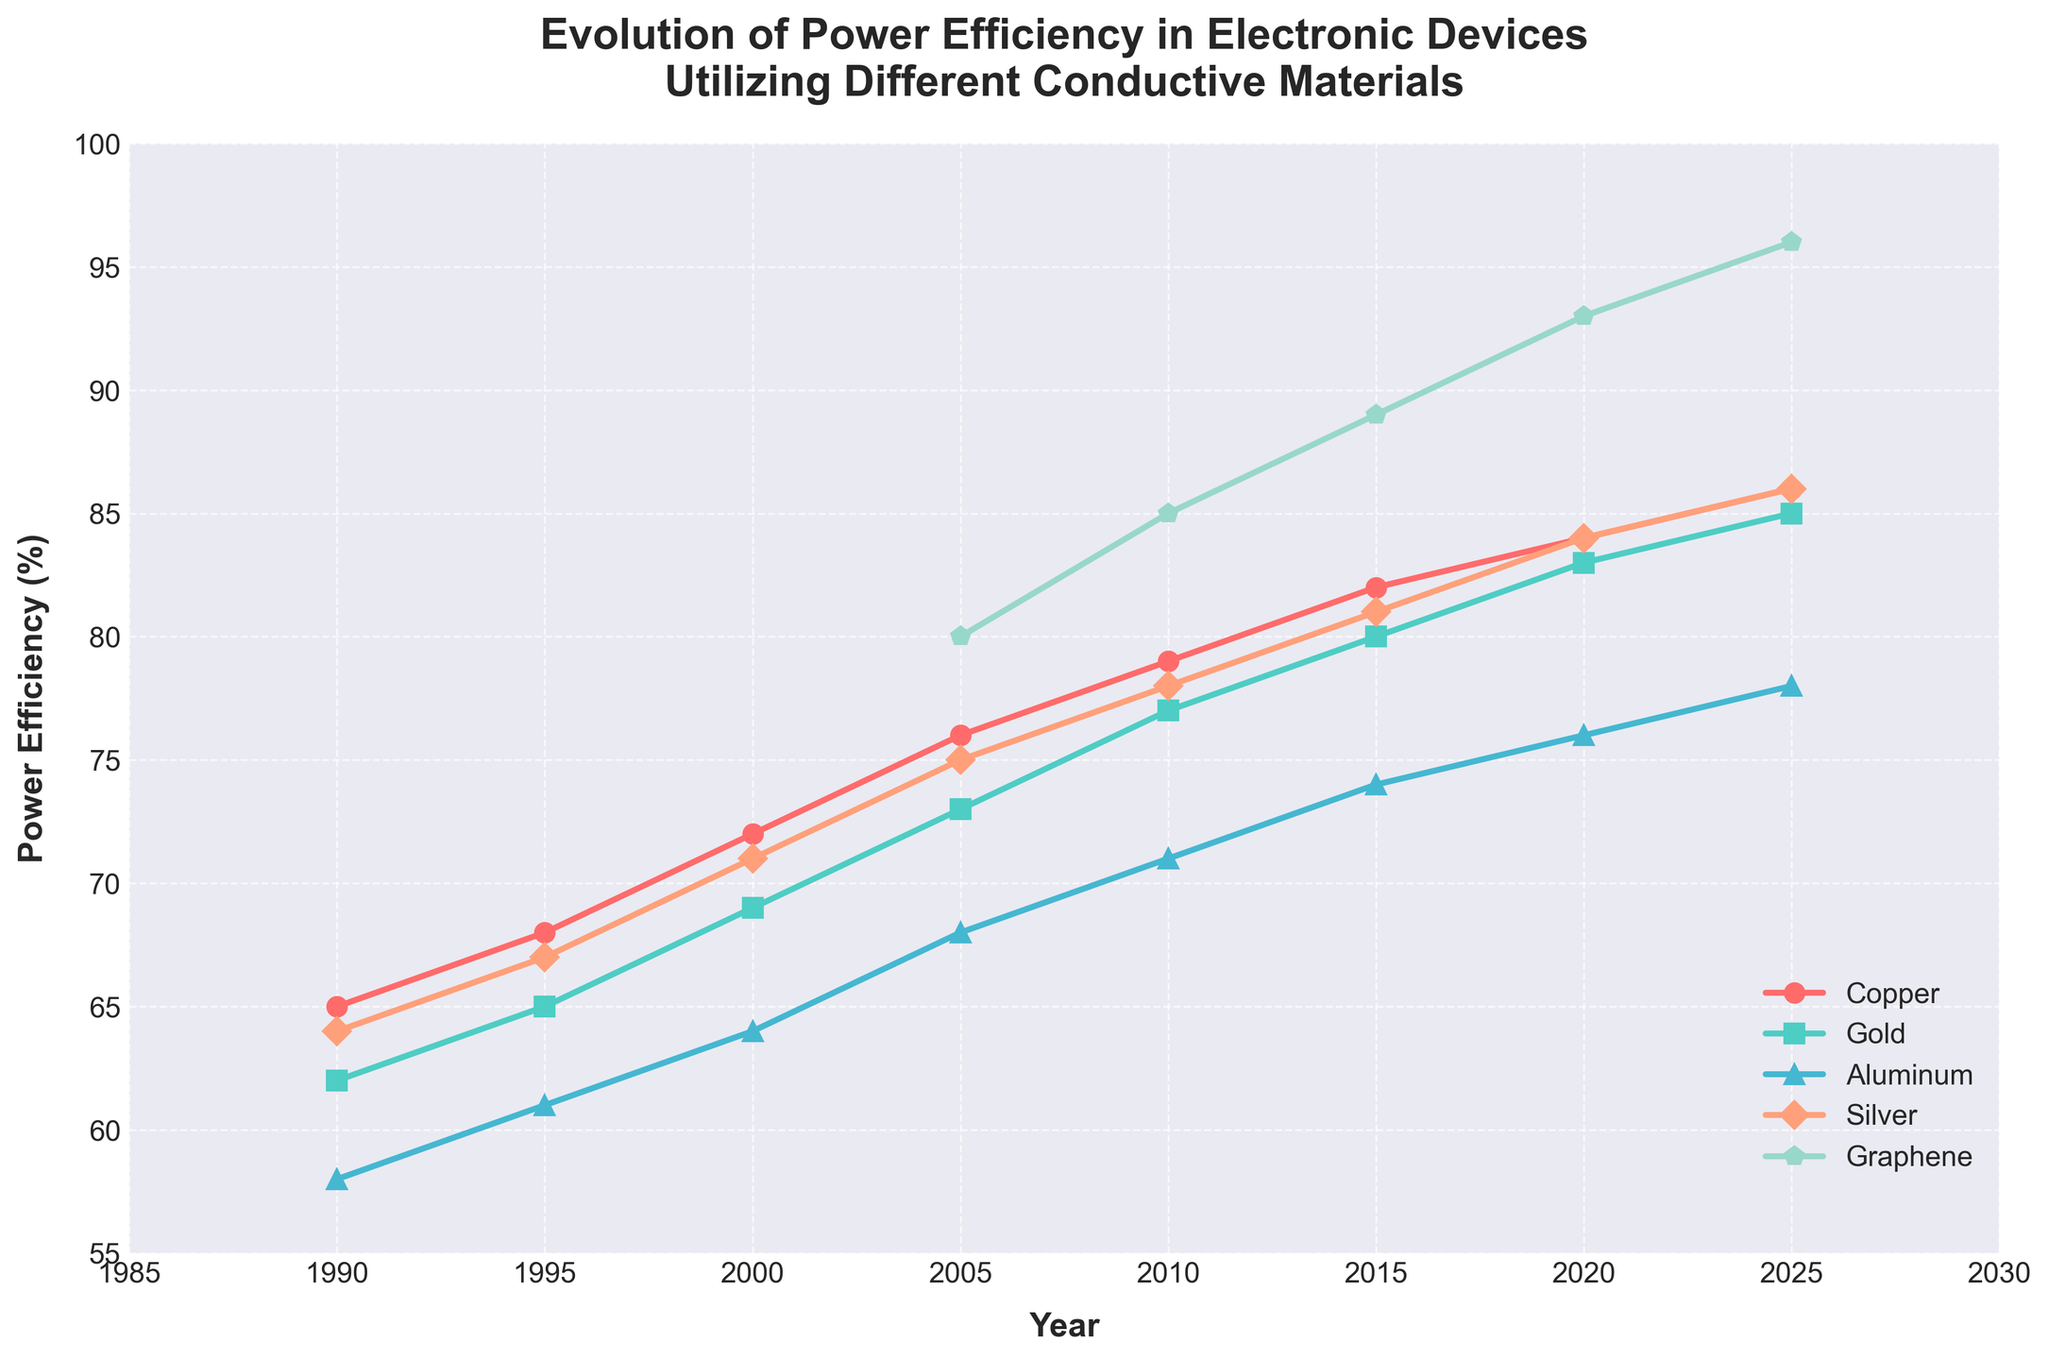How has the power efficiency of Copper and Aluminum changed from 1990 to 2025? To determine the change in power efficiency for Copper and Aluminum from 1990 to 2025, observe their power efficiency values in 1990 and 2025. For Copper, it increases from 65% to 86%, and for Aluminum, from 58% to 78%. Therefore, Copper's efficiency increased by 21% and Aluminum's by 20%.
Answer: Copper: +21%, Aluminum: +20% Which material had the highest power efficiency in 2010? Look at the power efficiency values for all materials in 2010. Graphene has the highest efficiency at 85%.
Answer: Graphene What is the average power efficiency of Silver between 2005 and 2025? To find the average, sum the values of Silver from 2005 to 2025 and divide by the number of data points: (75+78+81+84+86) / 5 = 80.8%.
Answer: 80.8% In which year did Graphene surpass Gold in power efficiency, and by how much? Compare Graphene’s and Gold's efficiencies year by year starting from 2005. In 2005, Graphene (80%) already surpassed Gold (73%), so Graphene surpassed Gold by 7% in 2005.
Answer: 2005, by 7% How does the trend in power efficiency of Copper compare to Gold from 1990 to 2025? Both Copper and Gold show an increasing trend in power efficiency over the years. Copper grew from 65% to 86% and Gold from 62% to 85%. The trend for both materials is positive, with Copper consistently maintaining slightly higher efficiency than Gold.
Answer: Both increasing, Copper consistently higher What is the difference in power efficiency between Silver and Graphene in 2020? Look at the power efficiency values for Silver and Graphene in 2020. Silver has 84% efficiency, and Graphene has 93%. The difference is 93% - 84% = 9%.
Answer: 9% Which material showed the most significant increase in power efficiency from 2000 to 2005? Compute the differences for each material between 2000 and 2005: Copper (76-72=4%), Gold (73-69=4%), Aluminum (68-64=4%), Silver (75-71=4%), Graphene (80- not applicable). No single material has the most significant increase as they all increase similarly.
Answer: All increased by 4% Which color line represents Gold in the plot? By looking at the description, the colors assigned to Gold is 'greenish'. The 'greenish' line corresponds to Gold.
Answer: Greenish color Is there any year when Graphene had lower power efficiency compared to Aluminum? Graphene appears in the data starting from 2005, and from 2005 onwards, Graphene’s efficiency is always higher than Aluminum's.
Answer: No What is the trend in power efficiency for all materials from 1990 to 2025? The graph shows a general upward trend for all materials, indicating improvements in power efficiency from 1990 to 2025.
Answer: Upward trend 